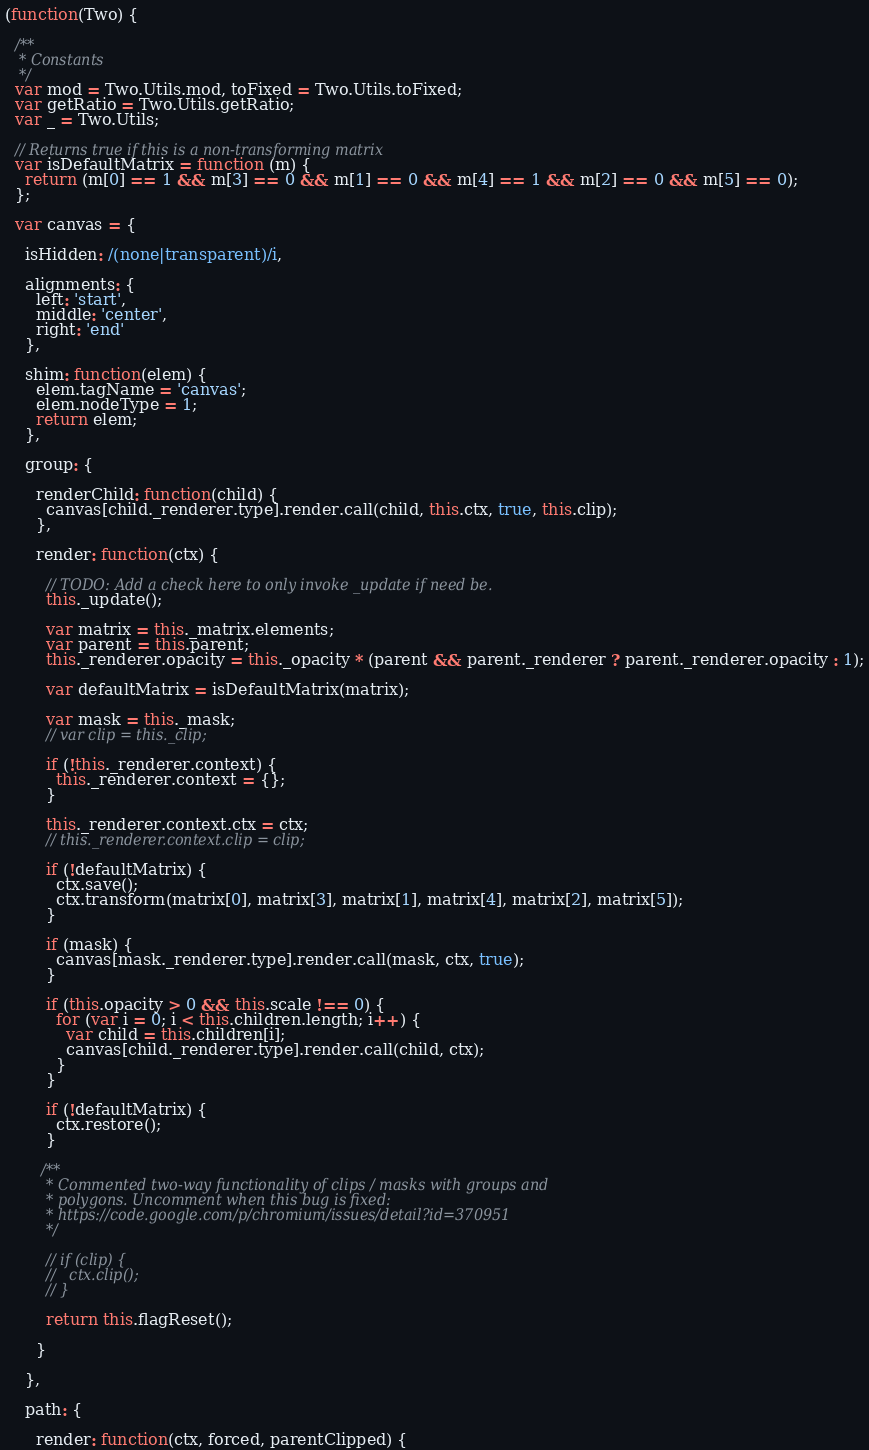<code> <loc_0><loc_0><loc_500><loc_500><_JavaScript_>(function(Two) {

  /**
   * Constants
   */
  var mod = Two.Utils.mod, toFixed = Two.Utils.toFixed;
  var getRatio = Two.Utils.getRatio;
  var _ = Two.Utils;

  // Returns true if this is a non-transforming matrix
  var isDefaultMatrix = function (m) {
    return (m[0] == 1 && m[3] == 0 && m[1] == 0 && m[4] == 1 && m[2] == 0 && m[5] == 0);
  };

  var canvas = {

    isHidden: /(none|transparent)/i,

    alignments: {
      left: 'start',
      middle: 'center',
      right: 'end'
    },

    shim: function(elem) {
      elem.tagName = 'canvas';
      elem.nodeType = 1;
      return elem;
    },

    group: {

      renderChild: function(child) {
        canvas[child._renderer.type].render.call(child, this.ctx, true, this.clip);
      },

      render: function(ctx) {

        // TODO: Add a check here to only invoke _update if need be.
        this._update();

        var matrix = this._matrix.elements;
        var parent = this.parent;
        this._renderer.opacity = this._opacity * (parent && parent._renderer ? parent._renderer.opacity : 1);

        var defaultMatrix = isDefaultMatrix(matrix);

        var mask = this._mask;
        // var clip = this._clip;

        if (!this._renderer.context) {
          this._renderer.context = {};
        }

        this._renderer.context.ctx = ctx;
        // this._renderer.context.clip = clip;

        if (!defaultMatrix) {
          ctx.save();
          ctx.transform(matrix[0], matrix[3], matrix[1], matrix[4], matrix[2], matrix[5]);
        }

        if (mask) {
          canvas[mask._renderer.type].render.call(mask, ctx, true);
        }

        if (this.opacity > 0 && this.scale !== 0) {
          for (var i = 0; i < this.children.length; i++) {
            var child = this.children[i];
            canvas[child._renderer.type].render.call(child, ctx);
          }
        }

        if (!defaultMatrix) {
          ctx.restore();
        }

       /**
         * Commented two-way functionality of clips / masks with groups and
         * polygons. Uncomment when this bug is fixed:
         * https://code.google.com/p/chromium/issues/detail?id=370951
         */

        // if (clip) {
        //   ctx.clip();
        // }

        return this.flagReset();

      }

    },

    path: {

      render: function(ctx, forced, parentClipped) {
</code> 